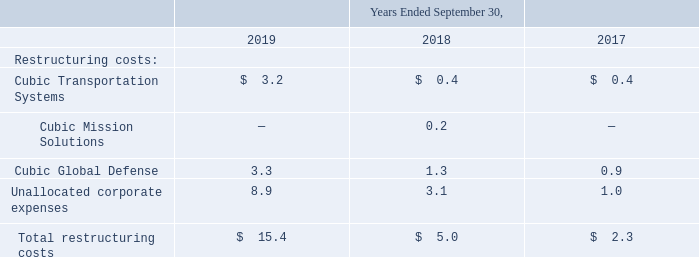NOTE 19—RESTRUCTURING
In 2019, we initiated projects to restructure and modify our supply chain strategy, functional responsibilities, methods, capabilities, processes and rationalize suppliers with the goal of reducing ongoing costs and increasing the efficiencies of our worldwide procurement organization. The majority of the costs associated with these restructuring activities are related to consultants that we have engaged in connection with these efforts, and such costs have been recognized by our corporate entity. The total costs of this restructuring project are expected to exceed amounts incurred to date by $0.9 million and these efforts are expected to be completed early in fiscal 2020. Also, in fiscal 2019 our CTS and CGD segments incurred restructuring charges, consisting primarily of employee severance costs related to headcount reductions initiated to optimize our cost positions. The total costs of each of these restructuring plans initiated thus far are not expected to be significantly greater than the charges incurred to date.
Our fiscal 2018 restructuring activities related primarily to expenses incurred by our corporate entity to establish a North American shared services center. Our fiscal 2017 restructuring activities included corporate efforts to increase the centralization and efficiency of our manufacturing processes, as well as restructuring charges incurred by our CGD businesses related to the elimination of a level of management in the CGD simulator business.
Restructuring charges incurred by our business segments were as follows (in millions):
What did the restructuring charges incurred by the CTS and CGD segments in 2019 consist primarily of? Consisting primarily of employee severance costs related to headcount reductions initiated to optimize our cost positions. What did the restructuring activities in 2017 include? Corporate efforts to increase the centralization and efficiency of our manufacturing processes, as well as restructuring charges incurred by our cgd businesses related to the elimination of a level of management in the cgd simulator business. What are the years included in the table? 2019, 2018, 2017. In which year was the restructuring costs incurred by Cubic Global Defense the lowest? 0.9<1.3<3.3
Answer: 2017. What is the change in the amount of total restructuring costs in 2019 from 2018?
Answer scale should be: million. 15.4-5.0
Answer: 10.4. What is the percentage change in the amount of total restructuring costs in 2019 from 2018?
Answer scale should be: percent. (15.4-5.0)/5.0
Answer: 208. 